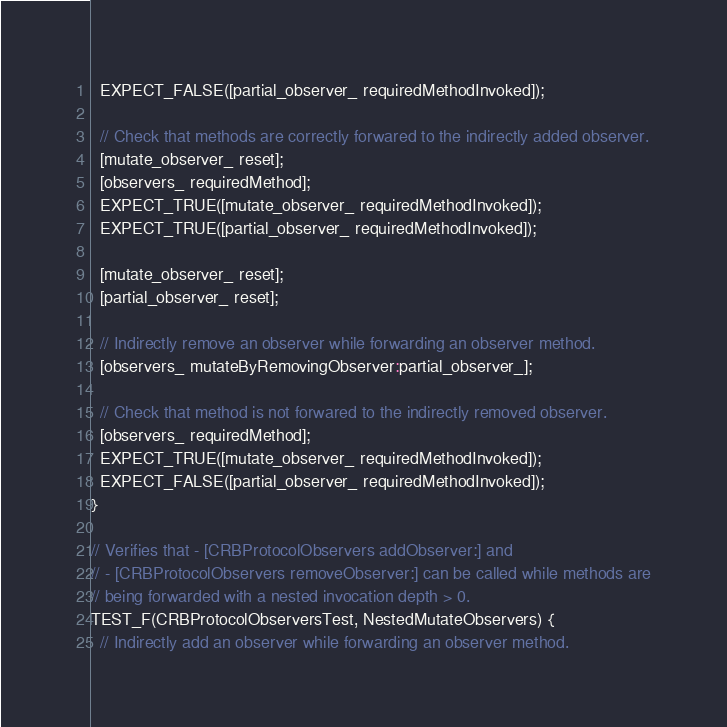Convert code to text. <code><loc_0><loc_0><loc_500><loc_500><_ObjectiveC_>  EXPECT_FALSE([partial_observer_ requiredMethodInvoked]);

  // Check that methods are correctly forwared to the indirectly added observer.
  [mutate_observer_ reset];
  [observers_ requiredMethod];
  EXPECT_TRUE([mutate_observer_ requiredMethodInvoked]);
  EXPECT_TRUE([partial_observer_ requiredMethodInvoked]);

  [mutate_observer_ reset];
  [partial_observer_ reset];

  // Indirectly remove an observer while forwarding an observer method.
  [observers_ mutateByRemovingObserver:partial_observer_];

  // Check that method is not forwared to the indirectly removed observer.
  [observers_ requiredMethod];
  EXPECT_TRUE([mutate_observer_ requiredMethodInvoked]);
  EXPECT_FALSE([partial_observer_ requiredMethodInvoked]);
}

// Verifies that - [CRBProtocolObservers addObserver:] and
// - [CRBProtocolObservers removeObserver:] can be called while methods are
// being forwarded with a nested invocation depth > 0.
TEST_F(CRBProtocolObserversTest, NestedMutateObservers) {
  // Indirectly add an observer while forwarding an observer method.</code> 